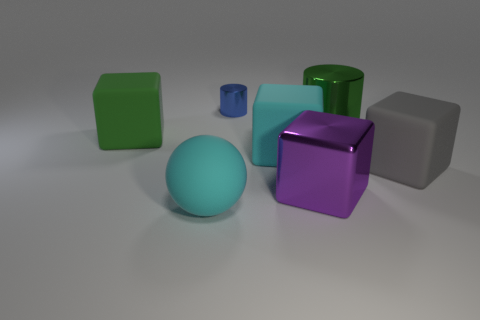Add 2 small blue balls. How many objects exist? 9 Subtract all big green rubber blocks. How many blocks are left? 3 Subtract all blue cylinders. How many cylinders are left? 1 Subtract all gray cubes. Subtract all big cyan matte balls. How many objects are left? 5 Add 5 big gray objects. How many big gray objects are left? 6 Add 2 blue metallic objects. How many blue metallic objects exist? 3 Subtract 1 cyan spheres. How many objects are left? 6 Subtract all cylinders. How many objects are left? 5 Subtract 1 spheres. How many spheres are left? 0 Subtract all blue cylinders. Subtract all brown balls. How many cylinders are left? 1 